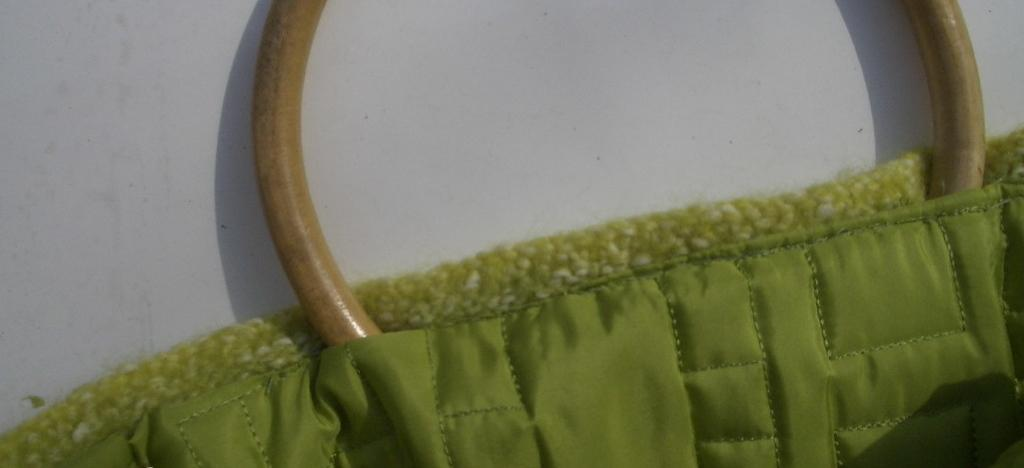What color is the cloth that is visible in the image? The cloth in the image is green. What type of object is present in the image alongside the green cloth? There is a wooden ring in the image. How is the wooden ring positioned in relation to the green cloth? The wooden ring is half in and half out of the green cloth. What is the value of the partner's dad in the image? There is no partner or dad present in the image; it only features a green cloth and a wooden ring. 